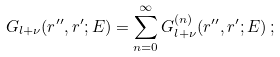Convert formula to latex. <formula><loc_0><loc_0><loc_500><loc_500>G _ { l + \nu } ( r ^ { \prime \prime } , r ^ { \prime } ; E ) = \sum _ { n = 0 } ^ { \infty } G _ { l + \nu } ^ { ( n ) } ( r ^ { \prime \prime } , r ^ { \prime } ; E ) \, ;</formula> 